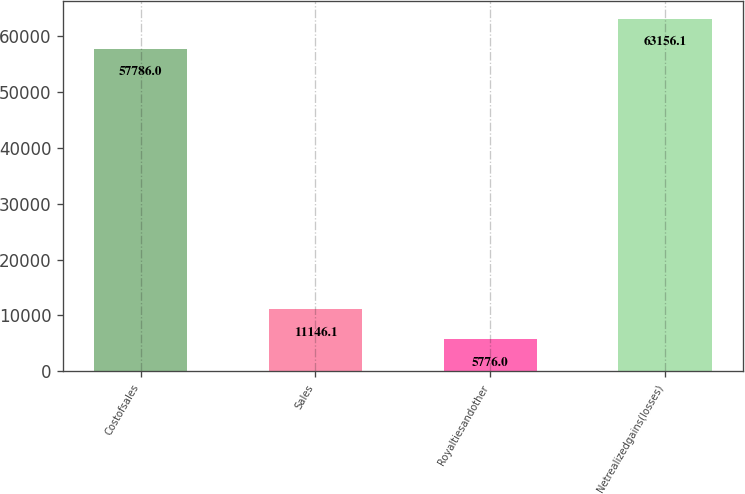Convert chart. <chart><loc_0><loc_0><loc_500><loc_500><bar_chart><fcel>Costofsales<fcel>Sales<fcel>Royaltiesandother<fcel>Netrealizedgains(losses)<nl><fcel>57786<fcel>11146.1<fcel>5776<fcel>63156.1<nl></chart> 